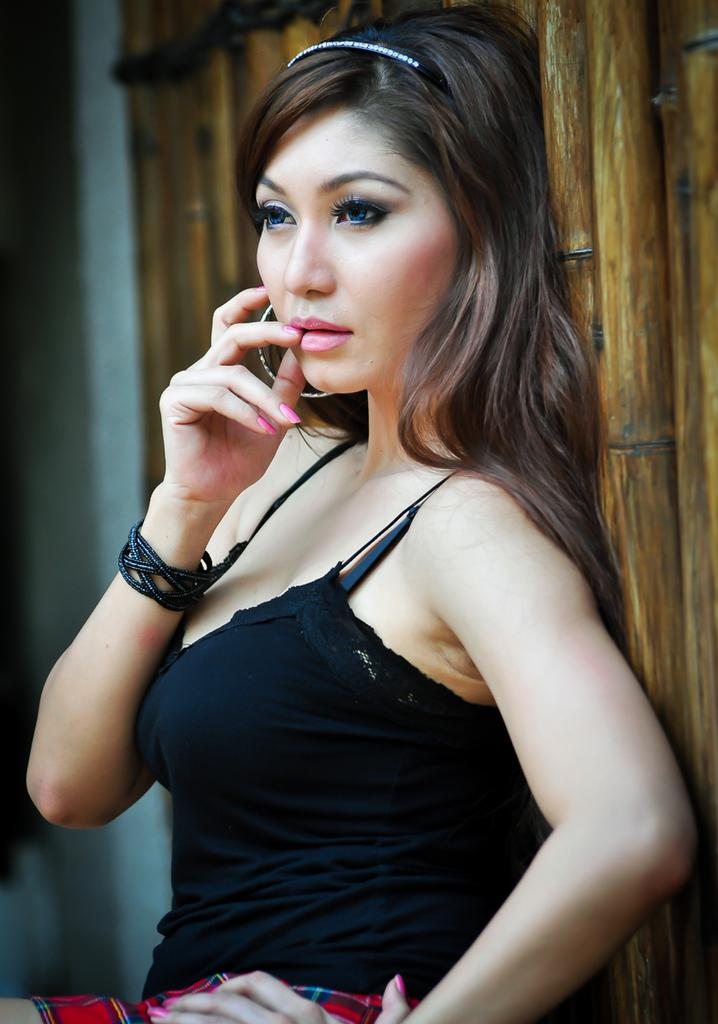Who is the main subject in the image? There is a lady in the image. What is the lady wearing? The lady is wearing a black dress. What can be seen in the background of the image? There is a fence in the background of the image. What type of art is the lady creating in the image? There is no indication in the image that the lady is creating any art. What kind of collar can be seen on the lady's pet in the image? There is no pet visible in the image, so it is not possible to determine if there is a collar present. 